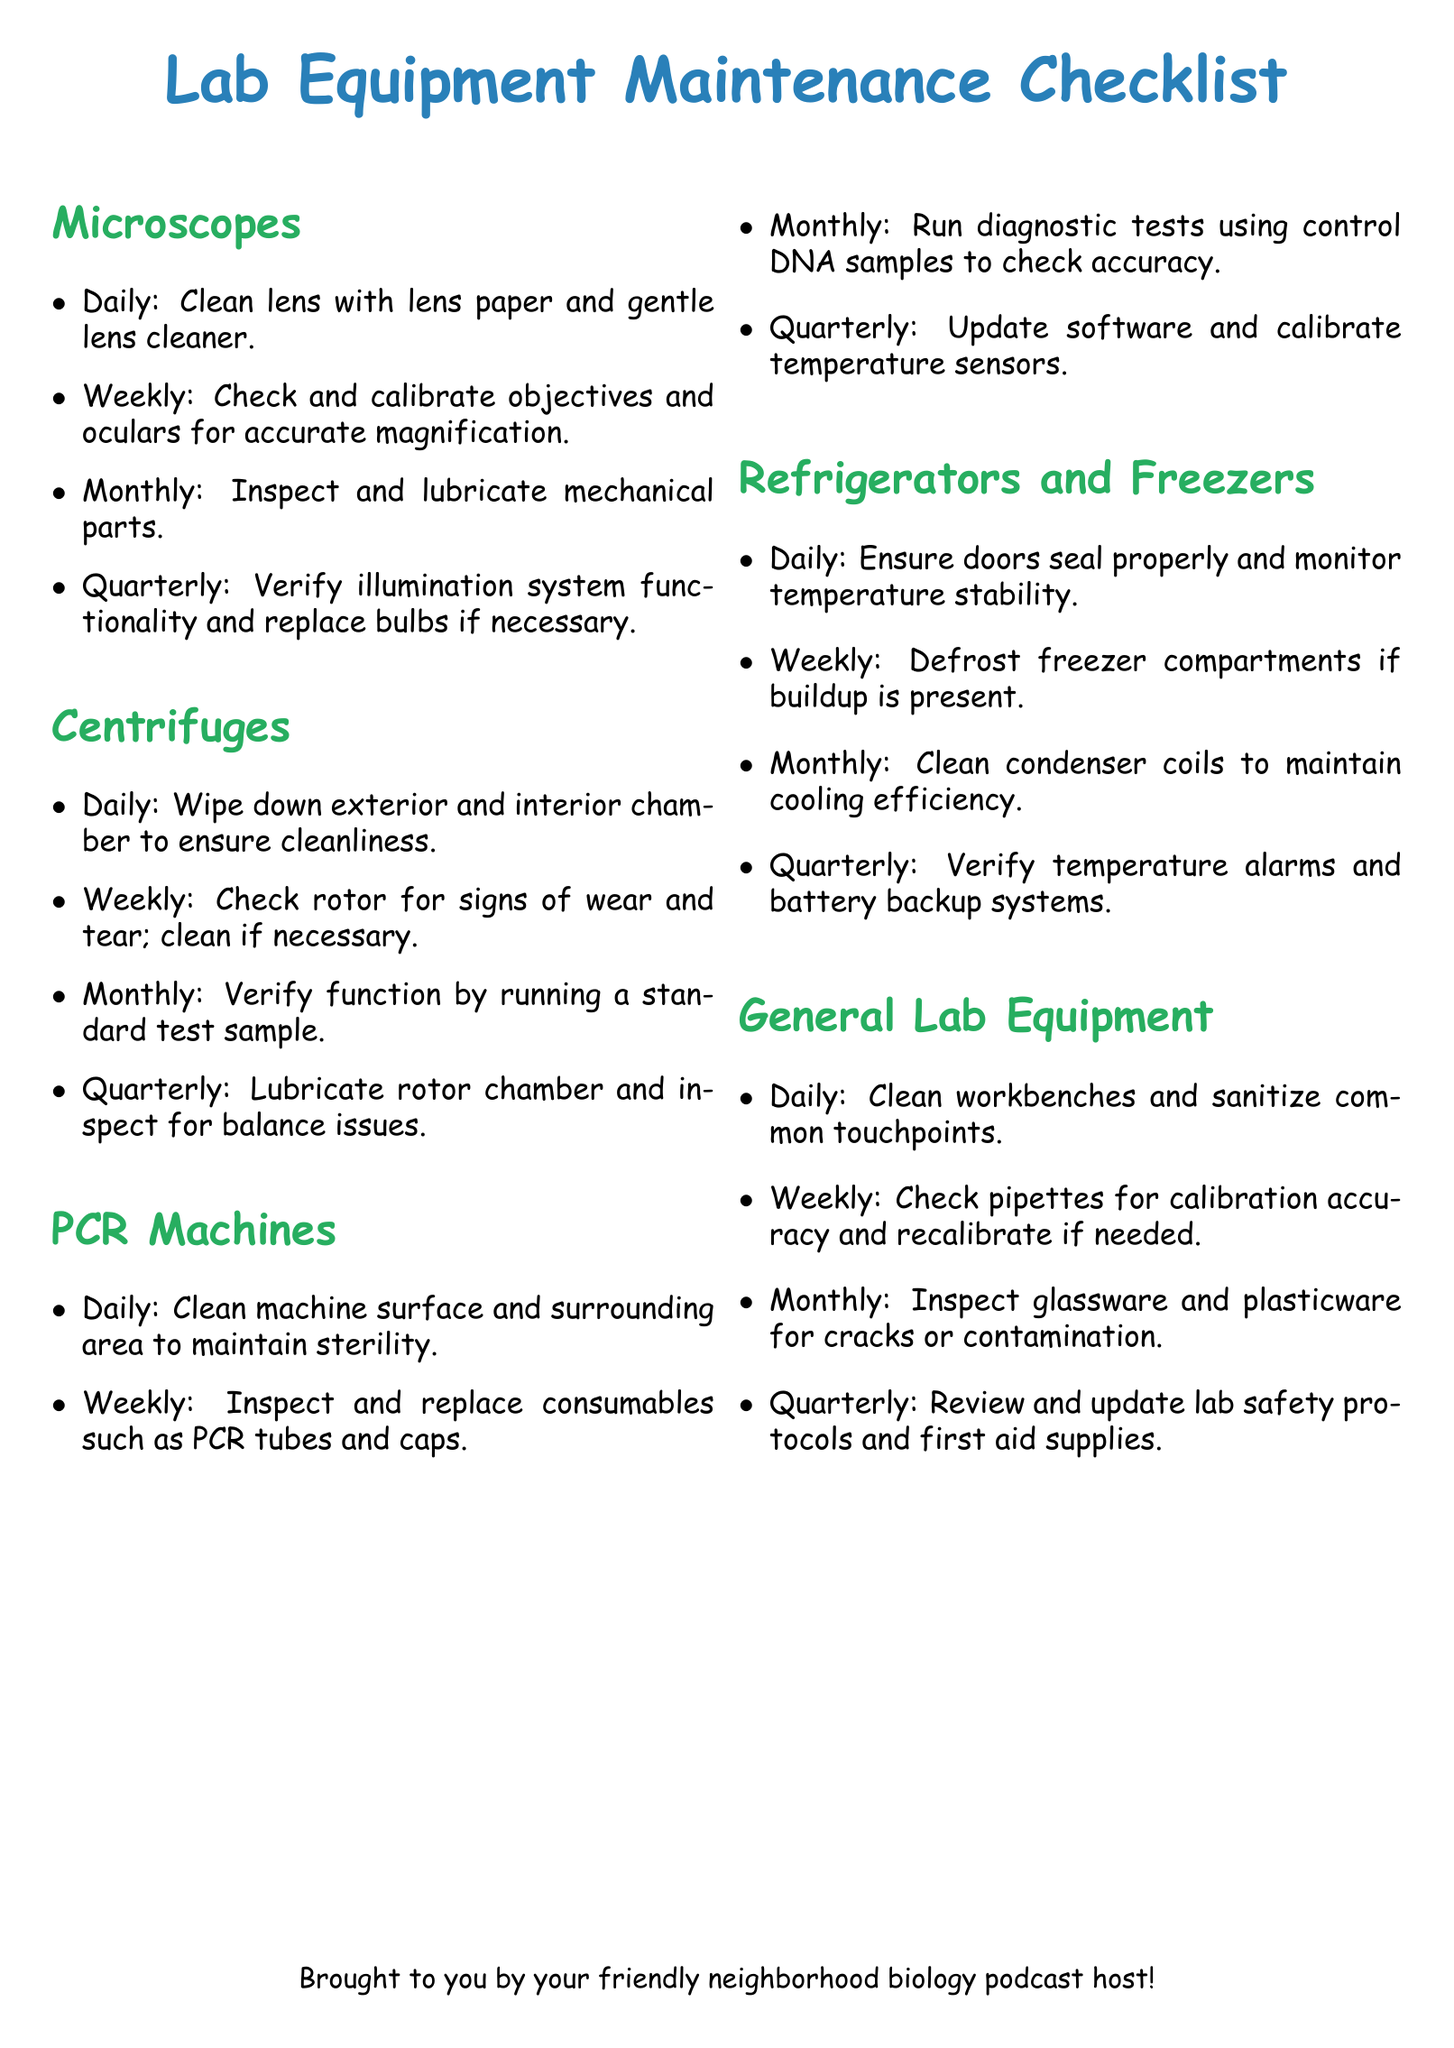What is the daily maintenance task for microscopes? The daily maintenance task involves cleaning the lens with lens paper and gentle lens cleaner.
Answer: Clean lens with lens paper and gentle lens cleaner How often should the condenser coils of refrigerators and freezers be cleaned? The document specifies that condenser coils should be cleaned on a monthly basis.
Answer: Monthly What is the quarterly maintenance requirement for PCR machines? The quarterly maintenance for PCR machines includes updating the software and calibrating temperature sensors.
Answer: Update software and calibrate temperature sensors What is the weekly task for centrifuges regarding the rotor? The weekly task for centrifuges is to check the rotor for signs of wear and tear and clean if necessary.
Answer: Check rotor for signs of wear and tear; clean if necessary How often should general lab equipment be inspected for cracks or contamination? General lab equipment should be inspected for cracks or contamination on a monthly basis.
Answer: Monthly What would indicate a temperature alarm and battery backup system verification? The verification of temperature alarms and battery backup systems is scheduled on a quarterly basis for refrigerators and freezers.
Answer: Quarterly Which cleaning task is performed daily for general lab equipment? For general lab equipment, the daily task is to clean workbenches and sanitize common touchpoints.
Answer: Clean workbenches and sanitize common touchpoints How frequently should the illumination system of microscopes be verified? The illumination system of microscopes must be verified quarterly.
Answer: Quarterly 